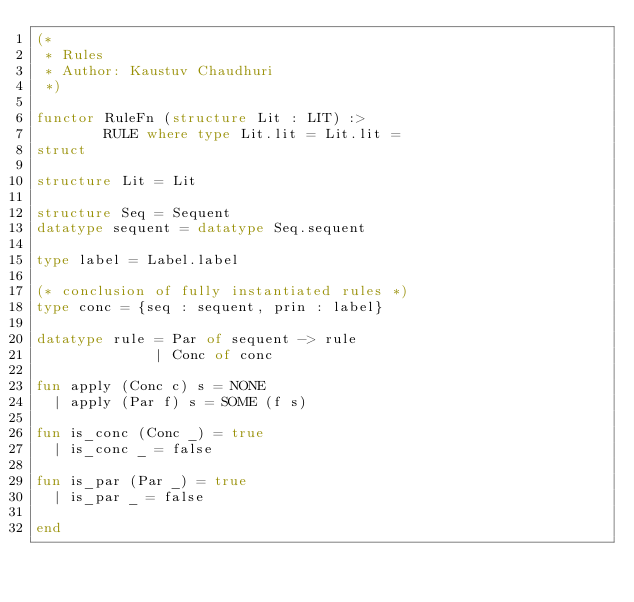<code> <loc_0><loc_0><loc_500><loc_500><_SML_>(* 
 * Rules
 * Author: Kaustuv Chaudhuri
 *)

functor RuleFn (structure Lit : LIT) :>
        RULE where type Lit.lit = Lit.lit =
struct

structure Lit = Lit

structure Seq = Sequent
datatype sequent = datatype Seq.sequent

type label = Label.label

(* conclusion of fully instantiated rules *)
type conc = {seq : sequent, prin : label}

datatype rule = Par of sequent -> rule
              | Conc of conc

fun apply (Conc c) s = NONE
  | apply (Par f) s = SOME (f s)

fun is_conc (Conc _) = true
  | is_conc _ = false

fun is_par (Par _) = true
  | is_par _ = false

end
</code> 